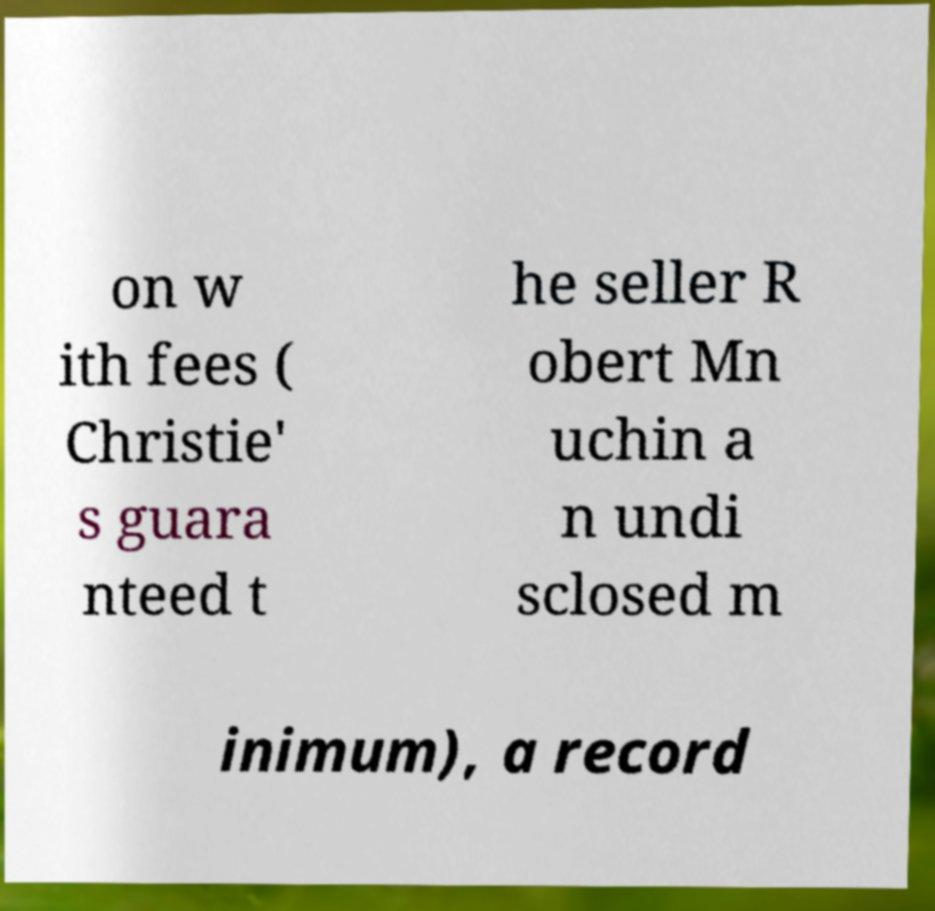Please identify and transcribe the text found in this image. on w ith fees ( Christie' s guara nteed t he seller R obert Mn uchin a n undi sclosed m inimum), a record 